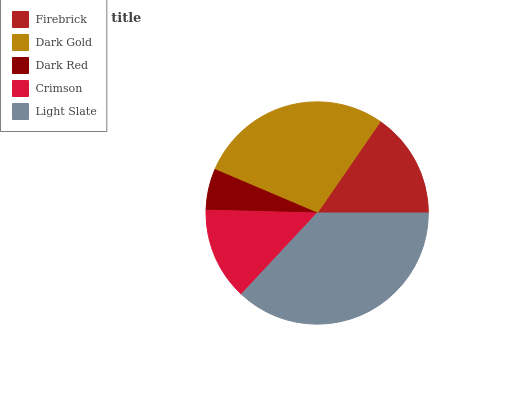Is Dark Red the minimum?
Answer yes or no. Yes. Is Light Slate the maximum?
Answer yes or no. Yes. Is Dark Gold the minimum?
Answer yes or no. No. Is Dark Gold the maximum?
Answer yes or no. No. Is Dark Gold greater than Firebrick?
Answer yes or no. Yes. Is Firebrick less than Dark Gold?
Answer yes or no. Yes. Is Firebrick greater than Dark Gold?
Answer yes or no. No. Is Dark Gold less than Firebrick?
Answer yes or no. No. Is Firebrick the high median?
Answer yes or no. Yes. Is Firebrick the low median?
Answer yes or no. Yes. Is Dark Red the high median?
Answer yes or no. No. Is Crimson the low median?
Answer yes or no. No. 